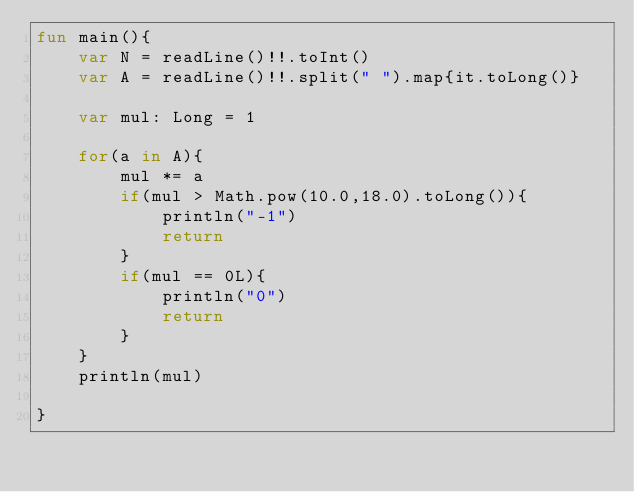<code> <loc_0><loc_0><loc_500><loc_500><_Kotlin_>fun main(){
    var N = readLine()!!.toInt()
    var A = readLine()!!.split(" ").map{it.toLong()}

    var mul: Long = 1

    for(a in A){
        mul *= a
        if(mul > Math.pow(10.0,18.0).toLong()){
            println("-1")
            return
        }
        if(mul == 0L){
            println("0")
            return
        }
    }
    println(mul)

}</code> 